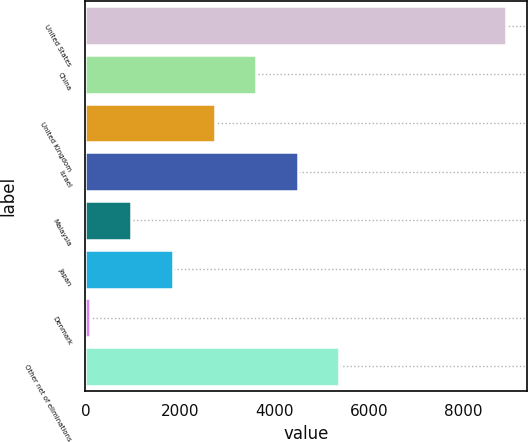Convert chart to OTSL. <chart><loc_0><loc_0><loc_500><loc_500><bar_chart><fcel>United States<fcel>China<fcel>United Kingdom<fcel>Israel<fcel>Malaysia<fcel>Japan<fcel>Denmark<fcel>Other net of eliminations<nl><fcel>8888<fcel>3611<fcel>2731.5<fcel>4490.5<fcel>972.5<fcel>1852<fcel>93<fcel>5370<nl></chart> 